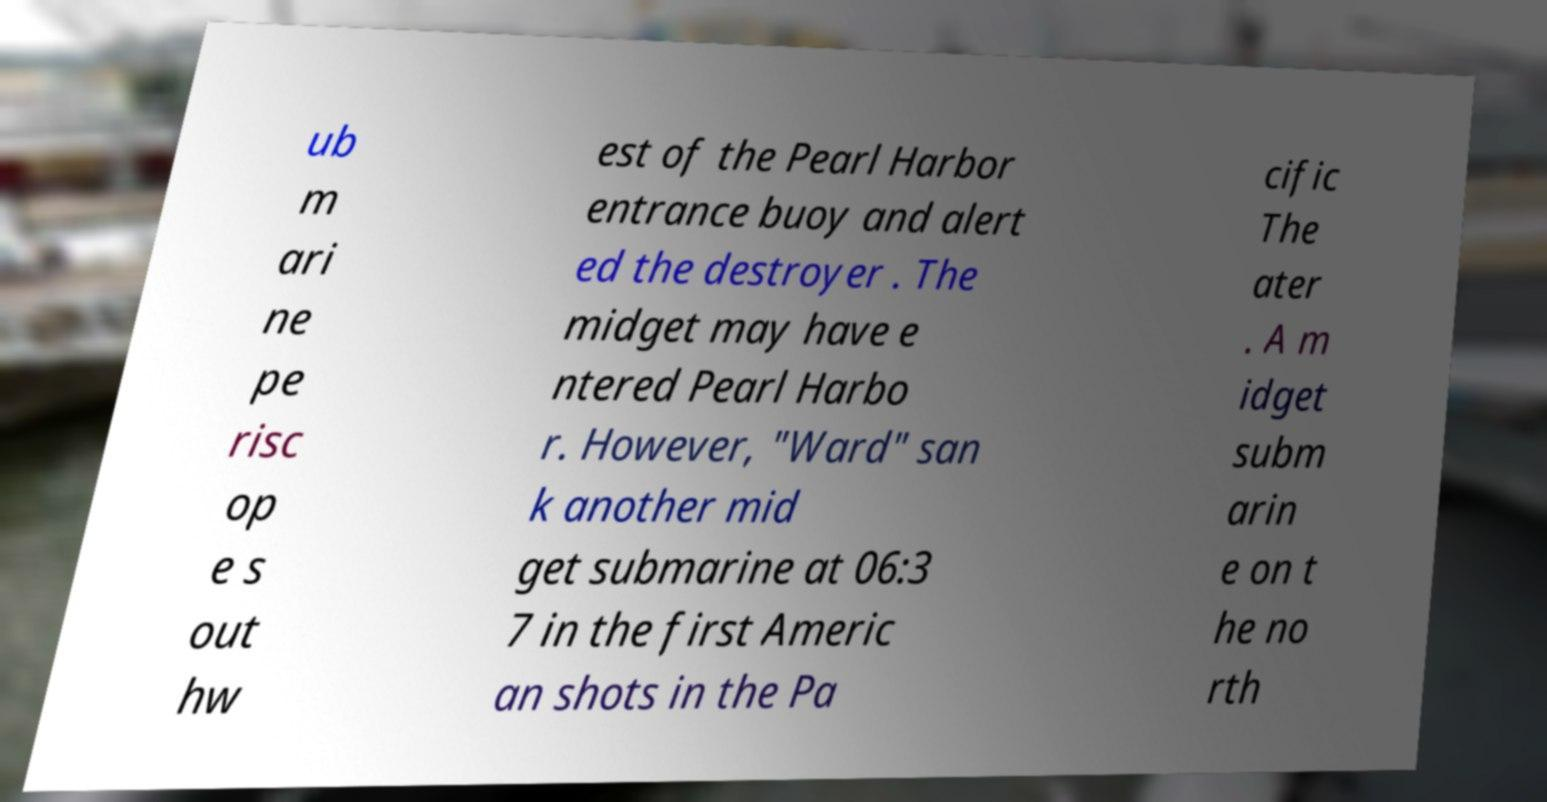Could you assist in decoding the text presented in this image and type it out clearly? ub m ari ne pe risc op e s out hw est of the Pearl Harbor entrance buoy and alert ed the destroyer . The midget may have e ntered Pearl Harbo r. However, "Ward" san k another mid get submarine at 06:3 7 in the first Americ an shots in the Pa cific The ater . A m idget subm arin e on t he no rth 